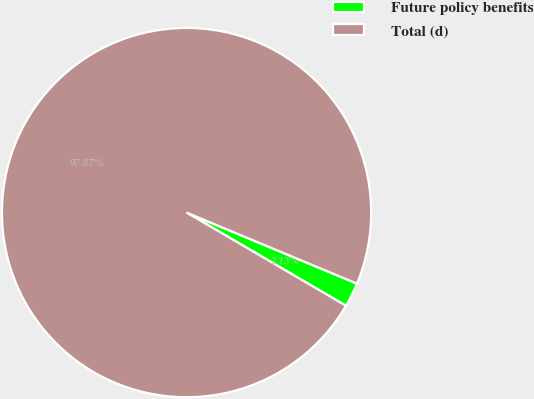<chart> <loc_0><loc_0><loc_500><loc_500><pie_chart><fcel>Future policy benefits<fcel>Total (d)<nl><fcel>2.13%<fcel>97.87%<nl></chart> 